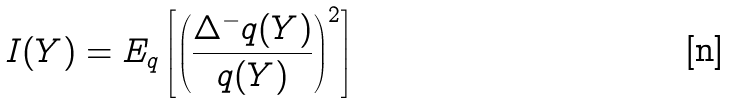Convert formula to latex. <formula><loc_0><loc_0><loc_500><loc_500>I ( Y ) = E _ { q } \left [ \left ( \frac { \Delta ^ { - } q ( Y ) } { q ( Y ) } \right ) ^ { 2 } \right ]</formula> 